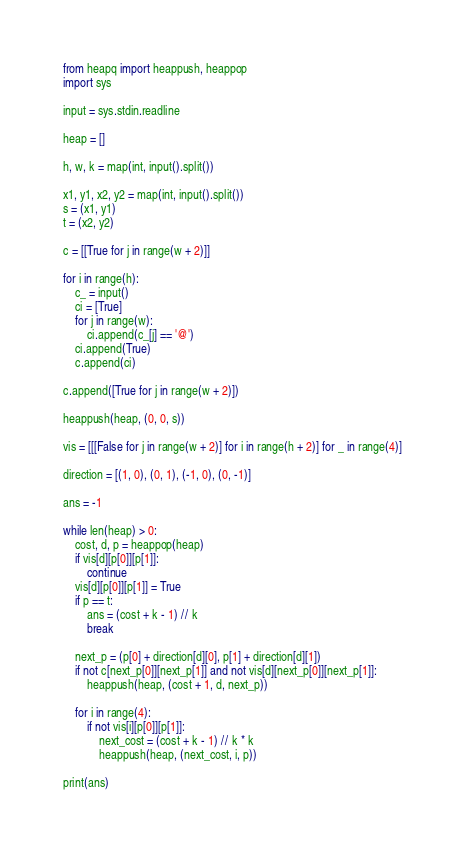Convert code to text. <code><loc_0><loc_0><loc_500><loc_500><_Python_>from heapq import heappush, heappop
import sys

input = sys.stdin.readline

heap = []

h, w, k = map(int, input().split())

x1, y1, x2, y2 = map(int, input().split())
s = (x1, y1)
t = (x2, y2)

c = [[True for j in range(w + 2)]]

for i in range(h):
    c_ = input()
    ci = [True]
    for j in range(w):
        ci.append(c_[j] == '@')
    ci.append(True)
    c.append(ci)

c.append([True for j in range(w + 2)])

heappush(heap, (0, 0, s))

vis = [[[False for j in range(w + 2)] for i in range(h + 2)] for _ in range(4)]

direction = [(1, 0), (0, 1), (-1, 0), (0, -1)]

ans = -1

while len(heap) > 0:
    cost, d, p = heappop(heap)
    if vis[d][p[0]][p[1]]:
        continue
    vis[d][p[0]][p[1]] = True
    if p == t:
        ans = (cost + k - 1) // k
        break

    next_p = (p[0] + direction[d][0], p[1] + direction[d][1])
    if not c[next_p[0]][next_p[1]] and not vis[d][next_p[0]][next_p[1]]:
        heappush(heap, (cost + 1, d, next_p))

    for i in range(4):
        if not vis[i][p[0]][p[1]]:
            next_cost = (cost + k - 1) // k * k
            heappush(heap, (next_cost, i, p))

print(ans)
</code> 